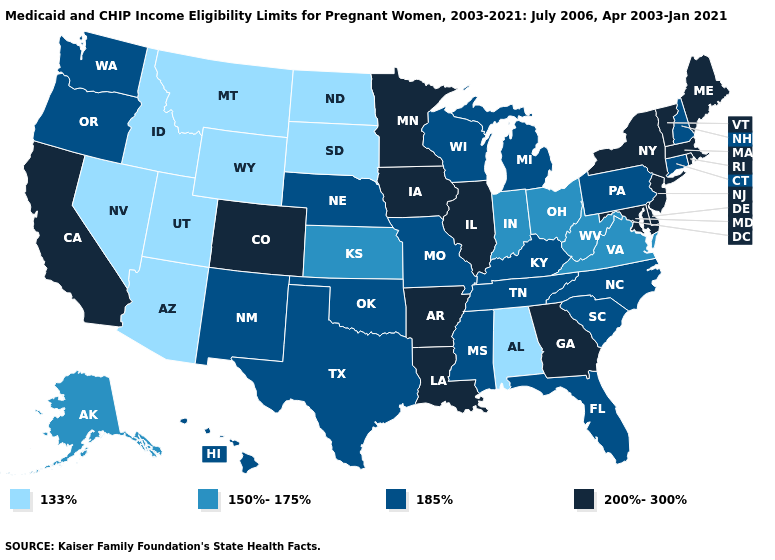What is the value of Texas?
Keep it brief. 185%. What is the highest value in states that border New Mexico?
Answer briefly. 200%-300%. What is the lowest value in the Northeast?
Write a very short answer. 185%. Name the states that have a value in the range 200%-300%?
Be succinct. Arkansas, California, Colorado, Delaware, Georgia, Illinois, Iowa, Louisiana, Maine, Maryland, Massachusetts, Minnesota, New Jersey, New York, Rhode Island, Vermont. Does Connecticut have a higher value than Washington?
Keep it brief. No. Is the legend a continuous bar?
Concise answer only. No. What is the value of Tennessee?
Short answer required. 185%. What is the value of New York?
Keep it brief. 200%-300%. Among the states that border Georgia , does Tennessee have the highest value?
Write a very short answer. Yes. Does the map have missing data?
Answer briefly. No. What is the value of Louisiana?
Write a very short answer. 200%-300%. Name the states that have a value in the range 185%?
Keep it brief. Connecticut, Florida, Hawaii, Kentucky, Michigan, Mississippi, Missouri, Nebraska, New Hampshire, New Mexico, North Carolina, Oklahoma, Oregon, Pennsylvania, South Carolina, Tennessee, Texas, Washington, Wisconsin. Among the states that border Nevada , which have the lowest value?
Quick response, please. Arizona, Idaho, Utah. What is the value of Montana?
Short answer required. 133%. Which states have the lowest value in the USA?
Give a very brief answer. Alabama, Arizona, Idaho, Montana, Nevada, North Dakota, South Dakota, Utah, Wyoming. 